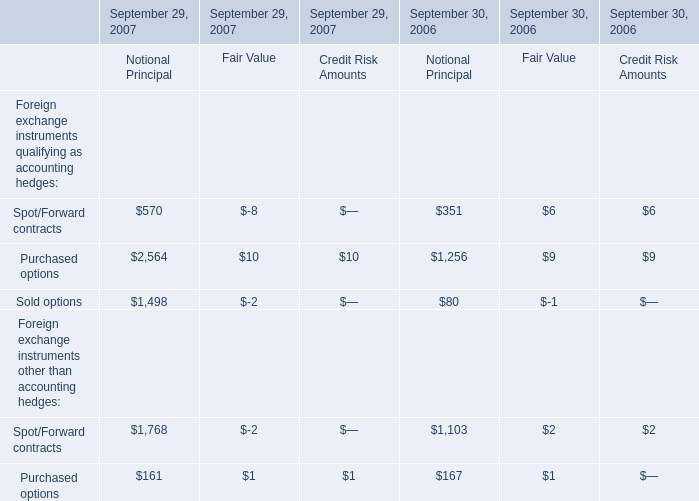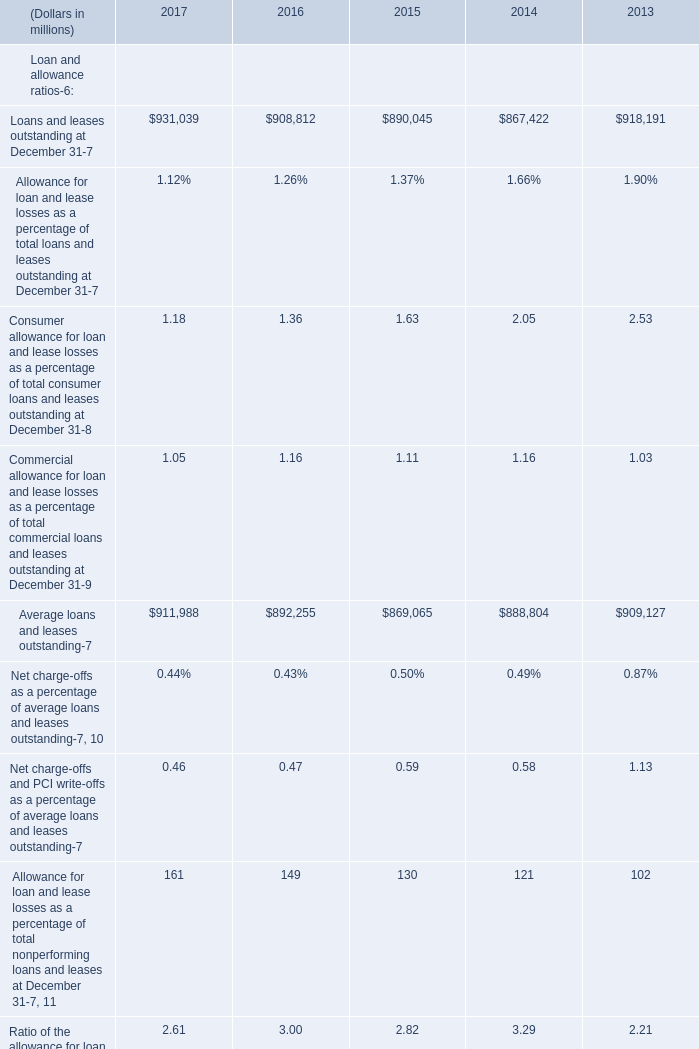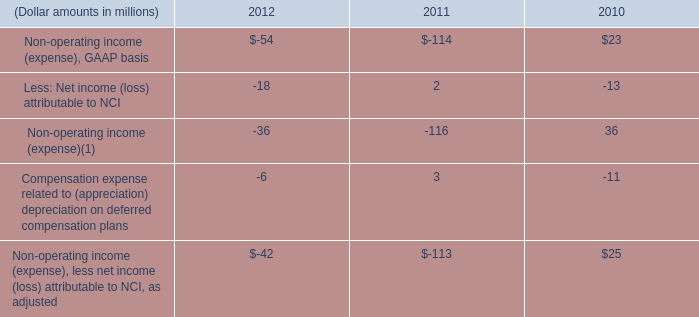what is the value of the non operating expenses between 2010 and 2012 ? in millions $ . 
Computations: ((54 + 114) - 23)
Answer: 145.0. 